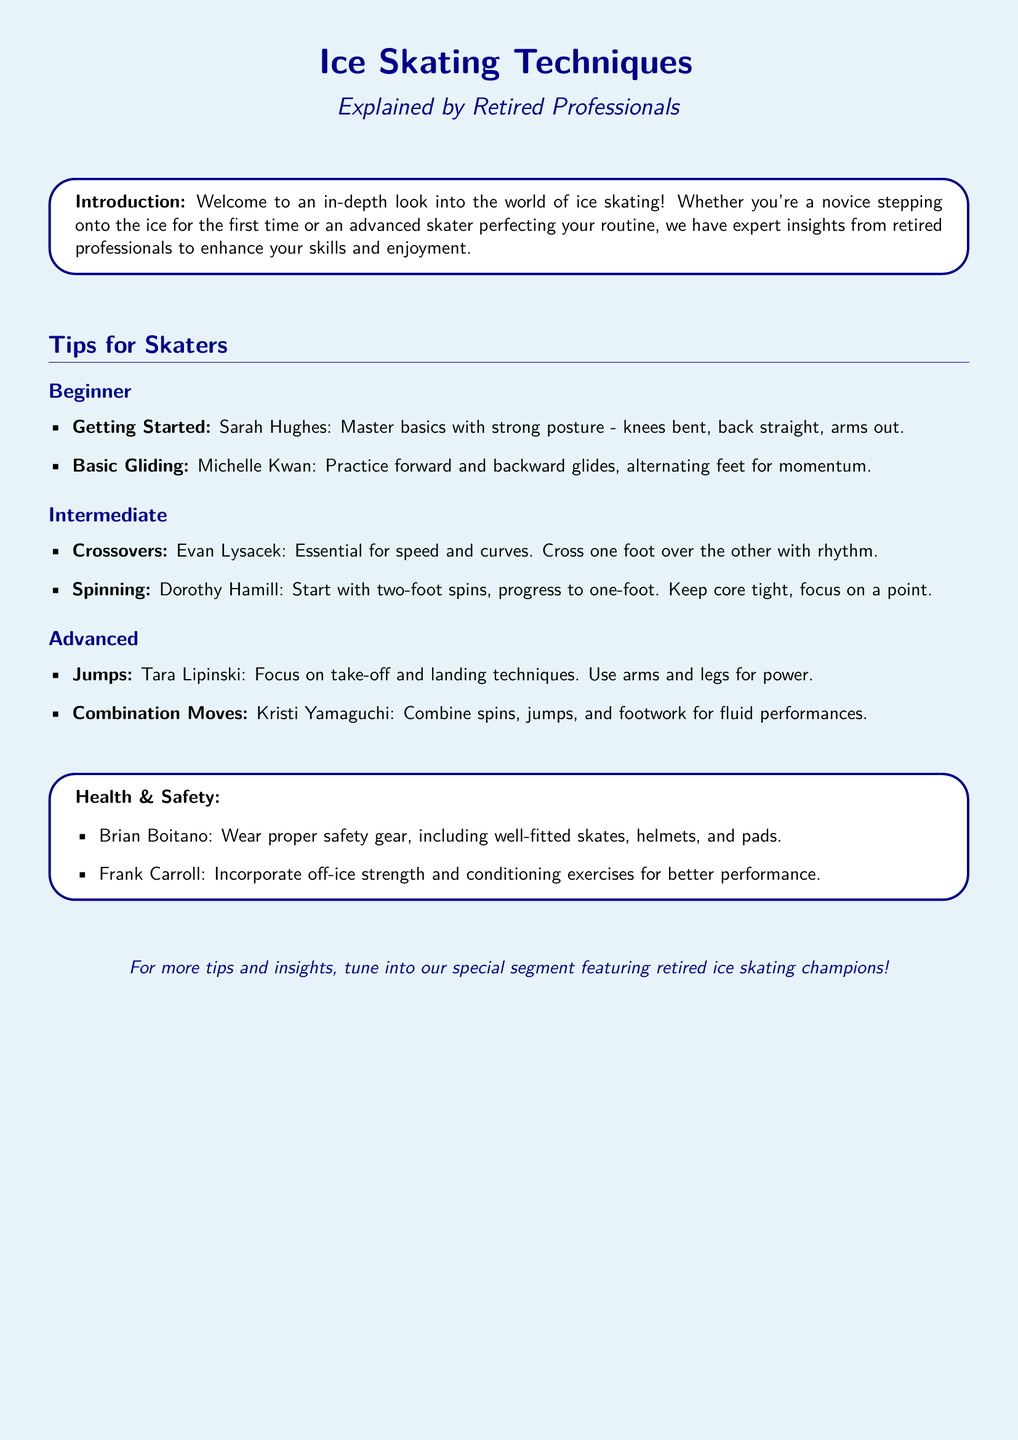What is the title of the document? The title is prominently featured at the top of the document.
Answer: Ice Skating Techniques Who provides tips for beginners? The document lists specific retired professional skaters associated with each tip category.
Answer: Sarah Hughes and Michelle Kwan What technique is essential for speed and curves? This information can be found under the intermediate tips section.
Answer: Crossovers What should skaters wear for safety? This advice is presented clearly in the health and safety section.
Answer: Proper safety gear Which skater emphasizes combination moves? Specific retired professionals are noted for their expertise in various techniques.
Answer: Kristi Yamaguchi What is recommended for better performance off the ice? The document suggests practices that can enhance skating skills outside of the rink.
Answer: Strength and conditioning exercises How many tip categories are included in the document? By counting the sections, we can determine this information.
Answer: Three What is stressed for basic gliding? This depends on what beginner skaters are advised to do regarding their gliding technique.
Answer: Forward and backward glides 